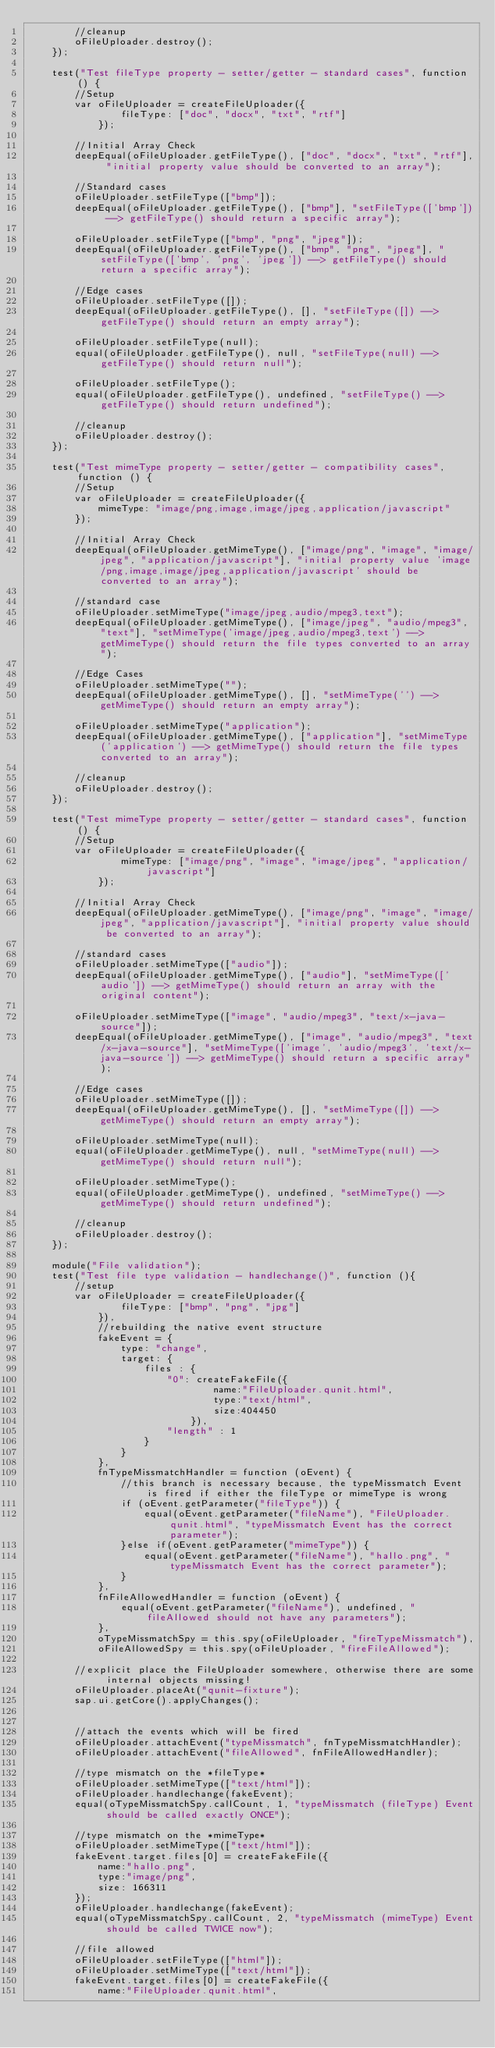<code> <loc_0><loc_0><loc_500><loc_500><_HTML_>		//cleanup
		oFileUploader.destroy();
	});

	test("Test fileType property - setter/getter - standard cases", function () {
		//Setup
		var oFileUploader = createFileUploader({
				fileType: ["doc", "docx", "txt", "rtf"]
			});

		//Initial Array Check
		deepEqual(oFileUploader.getFileType(), ["doc", "docx", "txt", "rtf"], "initial property value should be converted to an array");

		//Standard cases
		oFileUploader.setFileType(["bmp"]);
		deepEqual(oFileUploader.getFileType(), ["bmp"], "setFileType(['bmp']) --> getFileType() should return a specific array");

		oFileUploader.setFileType(["bmp", "png", "jpeg"]);
		deepEqual(oFileUploader.getFileType(), ["bmp", "png", "jpeg"], "setFileType(['bmp', 'png', 'jpeg']) --> getFileType() should return a specific array");

		//Edge cases
		oFileUploader.setFileType([]);
		deepEqual(oFileUploader.getFileType(), [], "setFileType([]) --> getFileType() should return an empty array");

		oFileUploader.setFileType(null);
		equal(oFileUploader.getFileType(), null, "setFileType(null) --> getFileType() should return null");

		oFileUploader.setFileType();
		equal(oFileUploader.getFileType(), undefined, "setFileType() --> getFileType() should return undefined");

		//cleanup
		oFileUploader.destroy();
	});

	test("Test mimeType property - setter/getter - compatibility cases", function () {
		//Setup
		var oFileUploader = createFileUploader({
			mimeType: "image/png,image,image/jpeg,application/javascript"
		});

		//Initial Array Check
		deepEqual(oFileUploader.getMimeType(), ["image/png", "image", "image/jpeg", "application/javascript"], "initial property value 'image/png,image,image/jpeg,application/javascript' should be converted to an array");

		//standard case
		oFileUploader.setMimeType("image/jpeg,audio/mpeg3,text");
		deepEqual(oFileUploader.getMimeType(), ["image/jpeg", "audio/mpeg3", "text"], "setMimeType('image/jpeg,audio/mpeg3,text') --> getMimeType() should return the file types converted to an array");

		//Edge Cases
		oFileUploader.setMimeType("");
		deepEqual(oFileUploader.getMimeType(), [], "setMimeType('') --> getMimeType() should return an empty array");

		oFileUploader.setMimeType("application");
		deepEqual(oFileUploader.getMimeType(), ["application"], "setMimeType('application') --> getMimeType() should return the file types converted to an array");

		//cleanup
		oFileUploader.destroy();
	});

	test("Test mimeType property - setter/getter - standard cases", function () {
		//Setup
		var oFileUploader = createFileUploader({
				mimeType: ["image/png", "image", "image/jpeg", "application/javascript"]
			});

		//Initial Array Check
		deepEqual(oFileUploader.getMimeType(), ["image/png", "image", "image/jpeg", "application/javascript"], "initial property value should be converted to an array");

		//standard cases
		oFileUploader.setMimeType(["audio"]);
		deepEqual(oFileUploader.getMimeType(), ["audio"], "setMimeType(['audio']) --> getMimeType() should return an array with the original content");

		oFileUploader.setMimeType(["image", "audio/mpeg3", "text/x-java-source"]);
		deepEqual(oFileUploader.getMimeType(), ["image", "audio/mpeg3", "text/x-java-source"], "setMimeType(['image', 'audio/mpeg3', 'text/x-java-source']) --> getMimeType() should return a specific array");

		//Edge cases
		oFileUploader.setMimeType([]);
		deepEqual(oFileUploader.getMimeType(), [], "setMimeType([]) --> getMimeType() should return an empty array");

		oFileUploader.setMimeType(null);
		equal(oFileUploader.getMimeType(), null, "setMimeType(null) --> getMimeType() should return null");

		oFileUploader.setMimeType();
		equal(oFileUploader.getMimeType(), undefined, "setMimeType() --> getMimeType() should return undefined");

		//cleanup
		oFileUploader.destroy();
	});

	module("File validation");
	test("Test file type validation - handlechange()", function (){
		//setup
		var oFileUploader = createFileUploader({
				fileType: ["bmp", "png", "jpg"]
			}),
			//rebuilding the native event structure
			fakeEvent = {
				type: "change",
				target: {
					files : {
						"0": createFakeFile({
								name:"FileUploader.qunit.html",
								type:"text/html",
								size:404450
							}),
						"length" : 1
					}
				}
			},
			fnTypeMissmatchHandler = function (oEvent) {
				//this branch is necessary because, the typeMissmatch Event is fired if either the fileType or mimeType is wrong
				if (oEvent.getParameter("fileType")) {
					equal(oEvent.getParameter("fileName"), "FileUploader.qunit.html", "typeMissmatch Event has the correct parameter");
				}else if(oEvent.getParameter("mimeType")) {
					equal(oEvent.getParameter("fileName"), "hallo.png", "typeMissmatch Event has the correct parameter");
				}
			},
			fnFileAllowedHandler = function (oEvent) {
				equal(oEvent.getParameter("fileName"), undefined, "fileAllowed should not have any parameters");
			},
			oTypeMissmatchSpy = this.spy(oFileUploader, "fireTypeMissmatch"),
			oFileAllowedSpy = this.spy(oFileUploader, "fireFileAllowed");

		//explicit place the FileUploader somewhere, otherwise there are some internal objects missing!
		oFileUploader.placeAt("qunit-fixture");
		sap.ui.getCore().applyChanges();


		//attach the events which will be fired
		oFileUploader.attachEvent("typeMissmatch", fnTypeMissmatchHandler);
		oFileUploader.attachEvent("fileAllowed", fnFileAllowedHandler);

		//type mismatch on the *fileType*
		oFileUploader.setMimeType(["text/html"]);
		oFileUploader.handlechange(fakeEvent);
		equal(oTypeMissmatchSpy.callCount, 1, "typeMissmatch (fileType) Event should be called exactly ONCE");

		//type mismatch on the *mimeType*
		oFileUploader.setMimeType(["text/html"]);
		fakeEvent.target.files[0] = createFakeFile({
			name:"hallo.png",
			type:"image/png",
			size: 166311
		});
		oFileUploader.handlechange(fakeEvent);
		equal(oTypeMissmatchSpy.callCount, 2, "typeMissmatch (mimeType) Event should be called TWICE now");

		//file allowed
		oFileUploader.setFileType(["html"]);
		oFileUploader.setMimeType(["text/html"]);
		fakeEvent.target.files[0] = createFakeFile({
			name:"FileUploader.qunit.html",</code> 